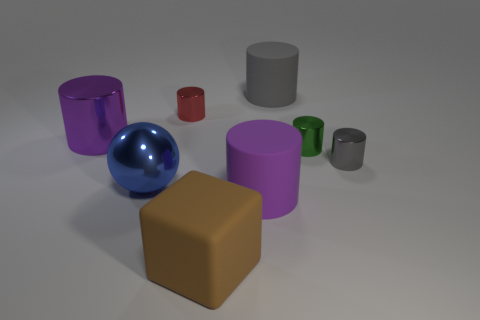How many cylinders are either small green metal objects or big gray things?
Your response must be concise. 2. How many small blue shiny cubes are there?
Your response must be concise. 0. There is a rubber cylinder on the right side of the big cylinder that is in front of the big blue thing; what size is it?
Your answer should be very brief. Large. What number of other things are the same size as the blue ball?
Offer a terse response. 4. What number of big metallic balls are behind the large sphere?
Your answer should be compact. 0. What size is the blue ball?
Provide a succinct answer. Large. Is the material of the large purple object that is to the left of the purple matte cylinder the same as the gray object behind the gray shiny thing?
Your answer should be very brief. No. Is there a matte cylinder that has the same color as the large block?
Your answer should be very brief. No. There is a shiny cylinder that is the same size as the rubber block; what color is it?
Ensure brevity in your answer.  Purple. Does the rubber cylinder that is in front of the red shiny object have the same color as the shiny ball?
Your response must be concise. No. 